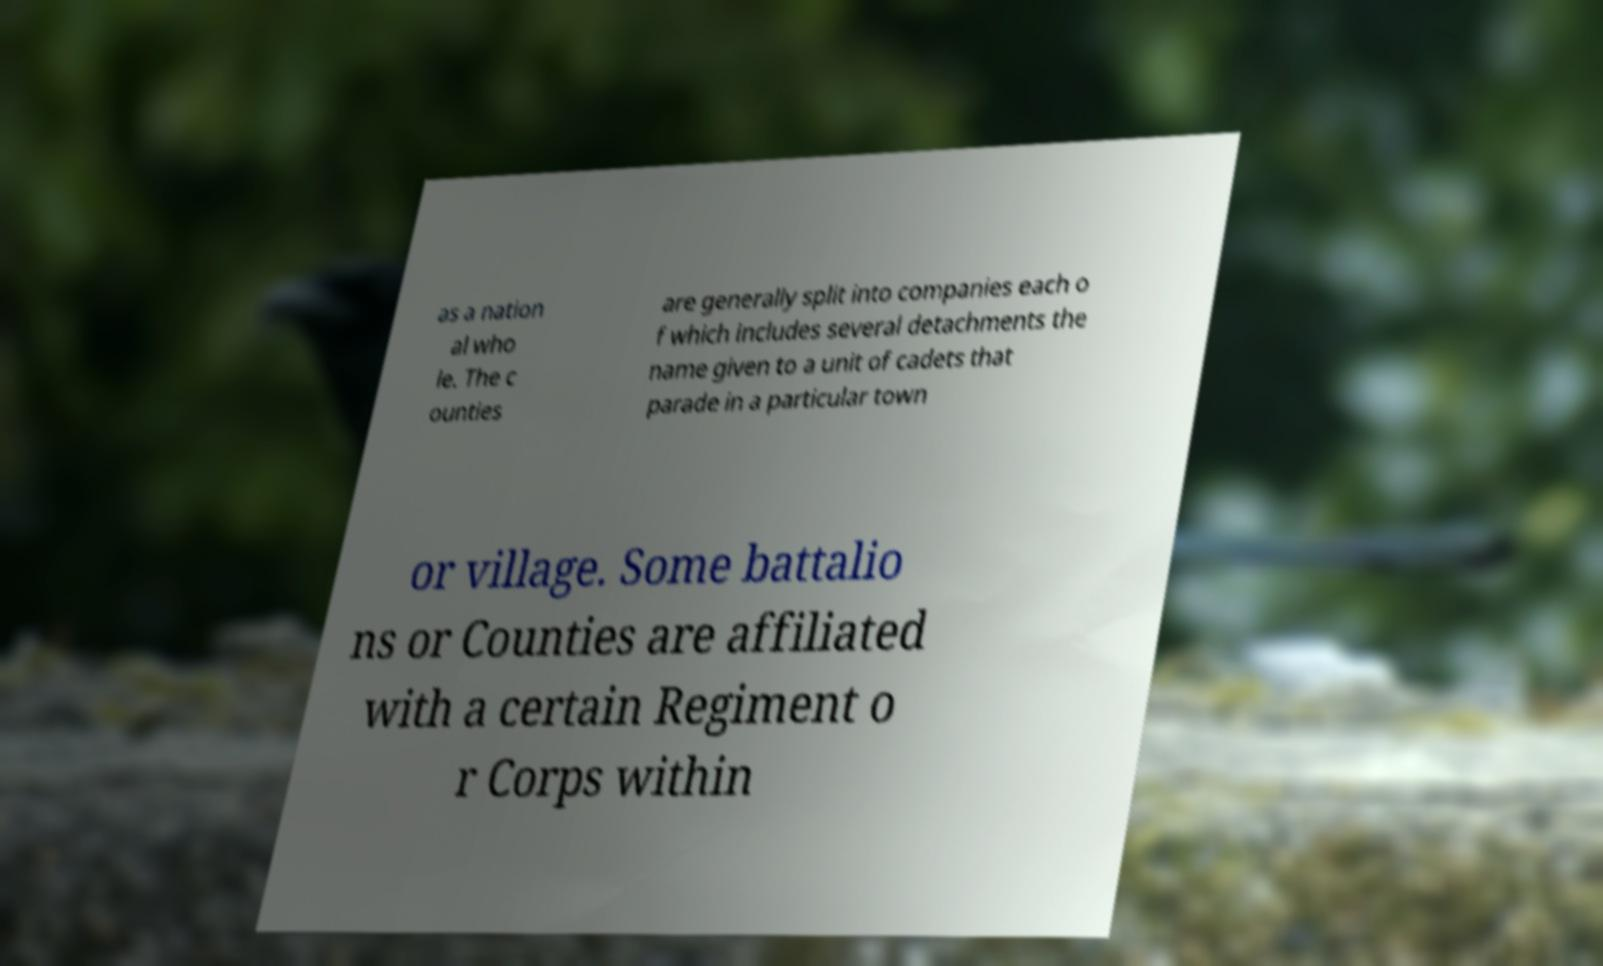I need the written content from this picture converted into text. Can you do that? as a nation al who le. The c ounties are generally split into companies each o f which includes several detachments the name given to a unit of cadets that parade in a particular town or village. Some battalio ns or Counties are affiliated with a certain Regiment o r Corps within 